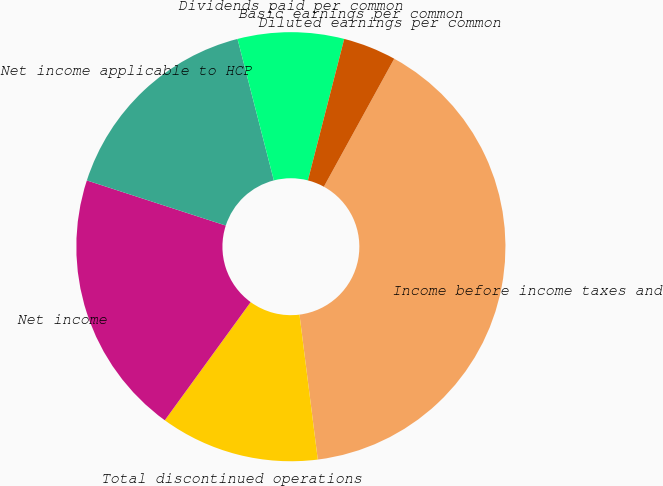Convert chart to OTSL. <chart><loc_0><loc_0><loc_500><loc_500><pie_chart><fcel>Income before income taxes and<fcel>Total discontinued operations<fcel>Net income<fcel>Net income applicable to HCP<fcel>Dividends paid per common<fcel>Basic earnings per common<fcel>Diluted earnings per common<nl><fcel>40.0%<fcel>12.0%<fcel>20.0%<fcel>16.0%<fcel>8.0%<fcel>0.0%<fcel>4.0%<nl></chart> 